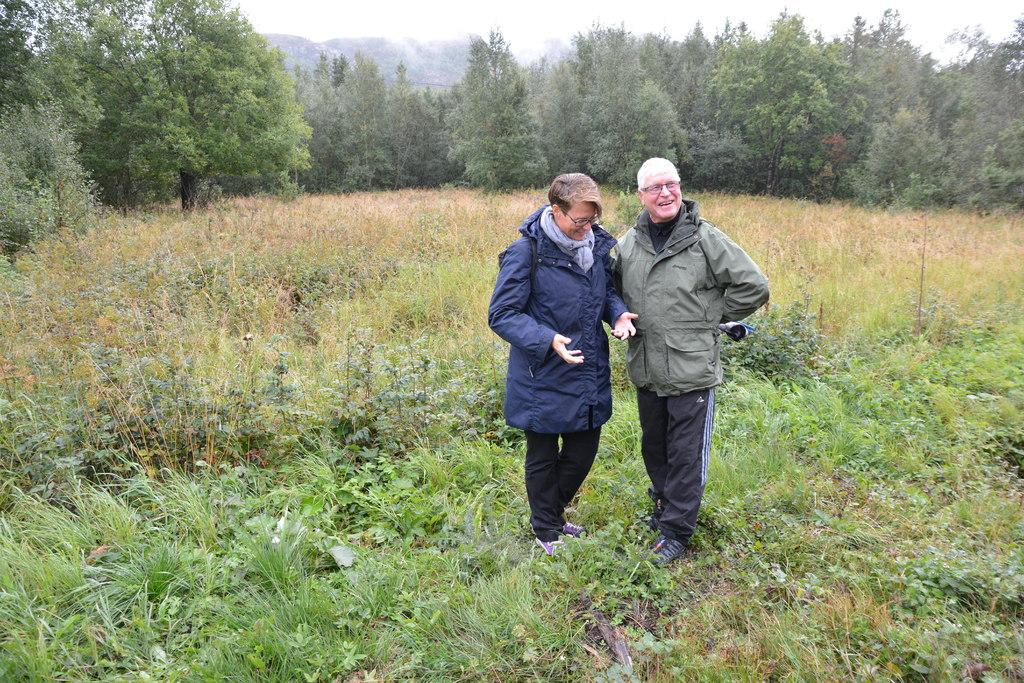What are the people in the image doing? The people in the image are standing. Where are the people standing in the image? The people are standing on the ground. What are the people wearing in the image? The people are wearing jackets. What is the ground covered with in the image? The ground is covered with grass. What can be seen in the background of the image? There are trees visible in the background. What type of watch is the person wearing in the image? There is no watch visible in the image; the people are wearing jackets. What kind of board game is being played by the people in the image? There is no board game present in the image; the people are standing on the ground. 